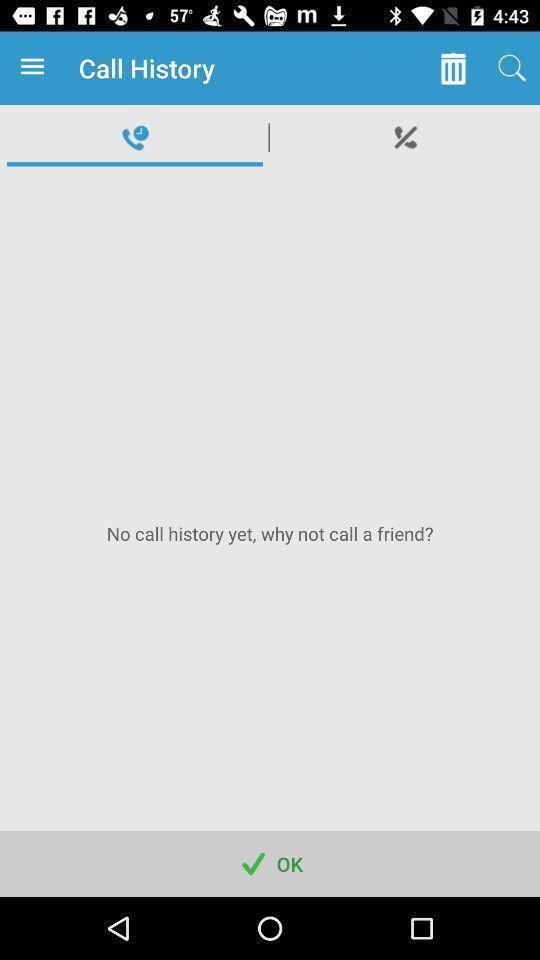Tell me about the visual elements in this screen capture. Screen displaying call history on calling and messaging app. 